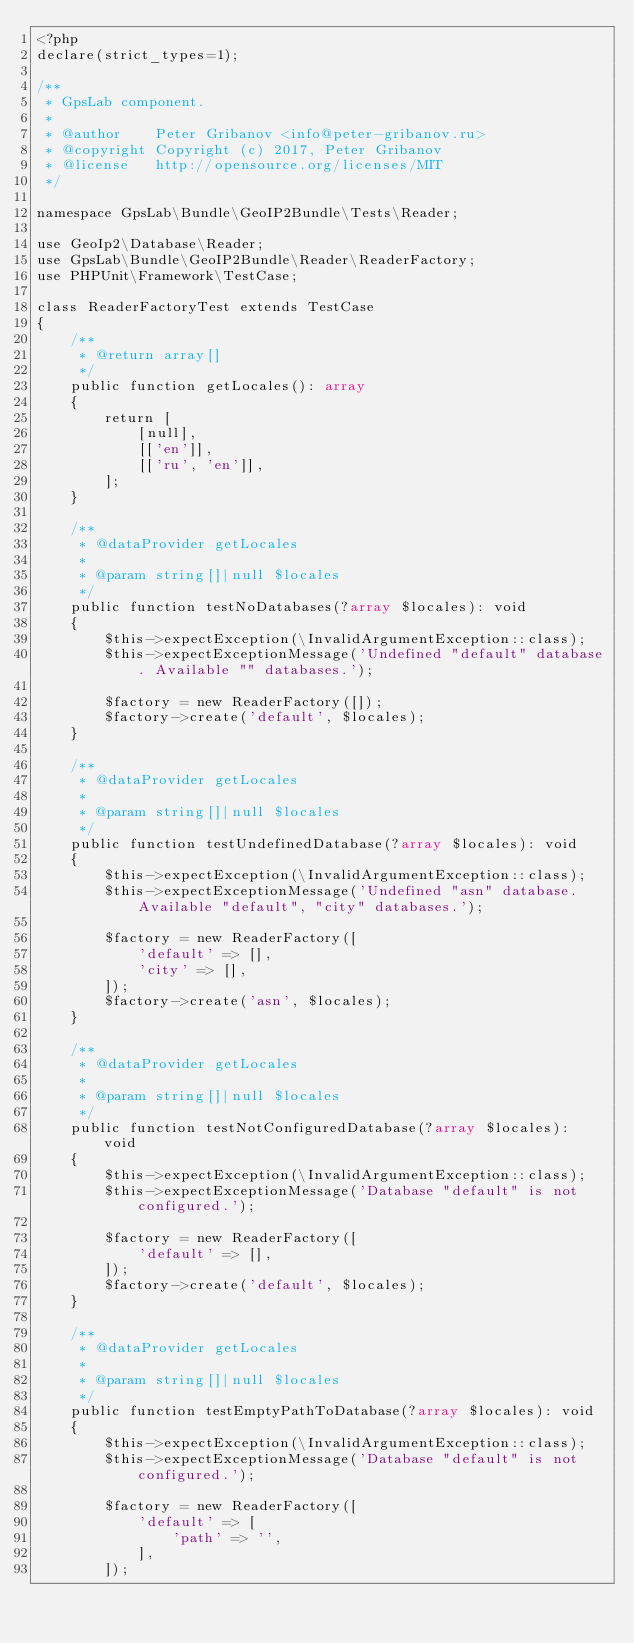Convert code to text. <code><loc_0><loc_0><loc_500><loc_500><_PHP_><?php
declare(strict_types=1);

/**
 * GpsLab component.
 *
 * @author    Peter Gribanov <info@peter-gribanov.ru>
 * @copyright Copyright (c) 2017, Peter Gribanov
 * @license   http://opensource.org/licenses/MIT
 */

namespace GpsLab\Bundle\GeoIP2Bundle\Tests\Reader;

use GeoIp2\Database\Reader;
use GpsLab\Bundle\GeoIP2Bundle\Reader\ReaderFactory;
use PHPUnit\Framework\TestCase;

class ReaderFactoryTest extends TestCase
{
    /**
     * @return array[]
     */
    public function getLocales(): array
    {
        return [
            [null],
            [['en']],
            [['ru', 'en']],
        ];
    }

    /**
     * @dataProvider getLocales
     *
     * @param string[]|null $locales
     */
    public function testNoDatabases(?array $locales): void
    {
        $this->expectException(\InvalidArgumentException::class);
        $this->expectExceptionMessage('Undefined "default" database. Available "" databases.');

        $factory = new ReaderFactory([]);
        $factory->create('default', $locales);
    }

    /**
     * @dataProvider getLocales
     *
     * @param string[]|null $locales
     */
    public function testUndefinedDatabase(?array $locales): void
    {
        $this->expectException(\InvalidArgumentException::class);
        $this->expectExceptionMessage('Undefined "asn" database. Available "default", "city" databases.');

        $factory = new ReaderFactory([
            'default' => [],
            'city' => [],
        ]);
        $factory->create('asn', $locales);
    }

    /**
     * @dataProvider getLocales
     *
     * @param string[]|null $locales
     */
    public function testNotConfiguredDatabase(?array $locales): void
    {
        $this->expectException(\InvalidArgumentException::class);
        $this->expectExceptionMessage('Database "default" is not configured.');

        $factory = new ReaderFactory([
            'default' => [],
        ]);
        $factory->create('default', $locales);
    }

    /**
     * @dataProvider getLocales
     *
     * @param string[]|null $locales
     */
    public function testEmptyPathToDatabase(?array $locales): void
    {
        $this->expectException(\InvalidArgumentException::class);
        $this->expectExceptionMessage('Database "default" is not configured.');

        $factory = new ReaderFactory([
            'default' => [
                'path' => '',
            ],
        ]);</code> 